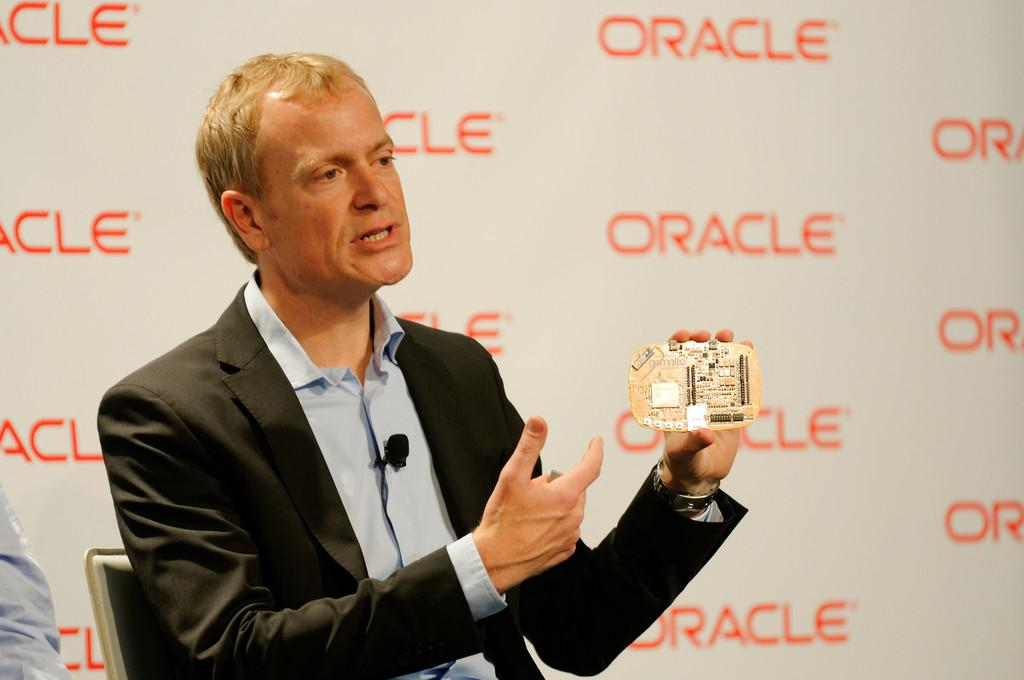What can be seen in the background of the image? There is a banner in the background of the image. What is the man in the image doing? The man is sitting on a chair in the image. What is the man holding in the image? The man is holding an object in the image. What might the man be doing based on his body language? The man appears to be talking in the image. What type of pump can be seen in the image? There is no pump present in the image. How does the man plan to join the group in the image? The image does not show the man joining a group, nor is there any indication of a group present. 